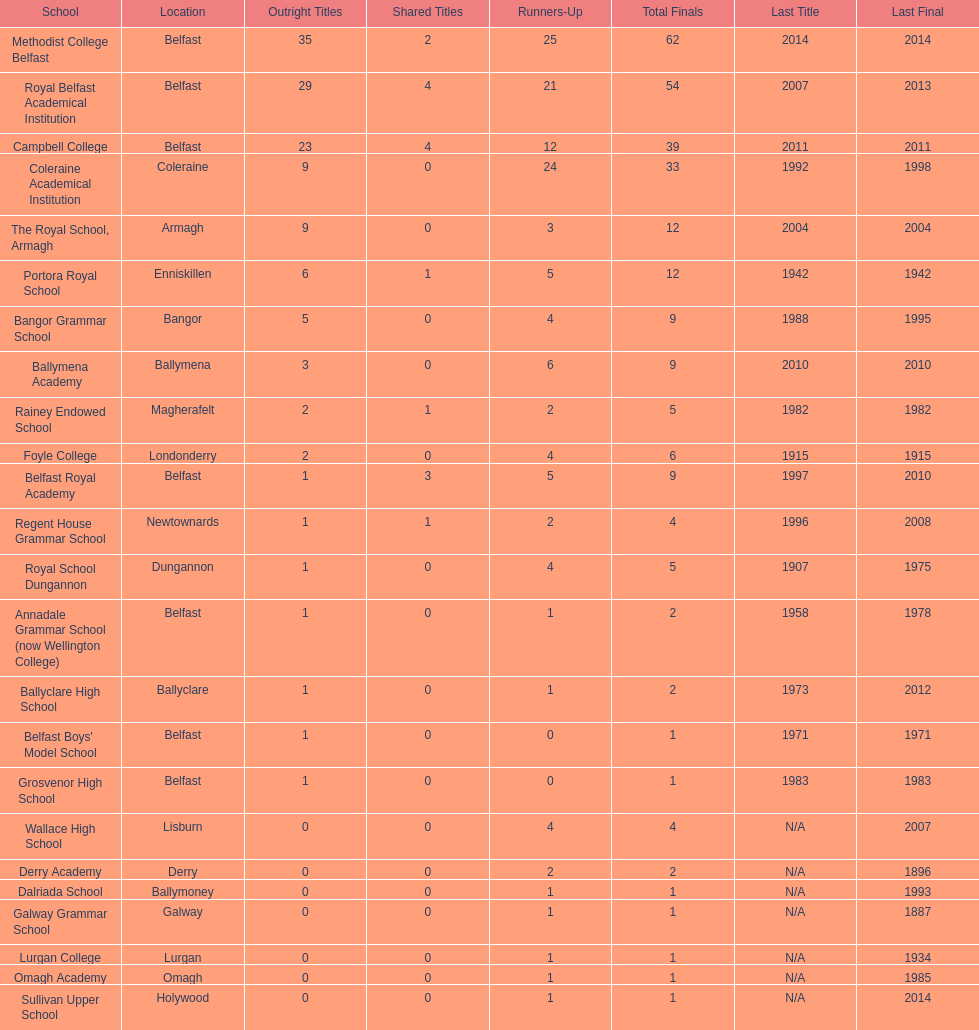How many educational institutions have experienced 3 or more shared title wins? 3. 